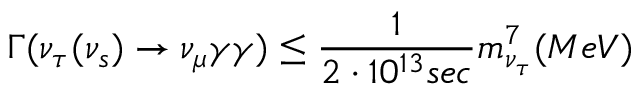Convert formula to latex. <formula><loc_0><loc_0><loc_500><loc_500>\Gamma ( \nu _ { \tau } ( \nu _ { s } ) \rightarrow \nu _ { \mu } \gamma \gamma ) \leq \frac { 1 } { 2 \cdot 1 0 ^ { 1 3 } s e c } m _ { \nu _ { \tau } } ^ { 7 } ( M e V )</formula> 